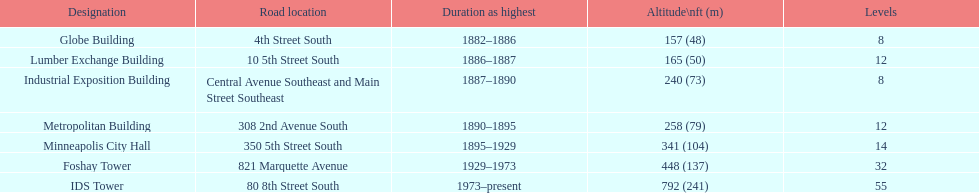After ids tower what is the second tallest building in minneapolis? Foshay Tower. 